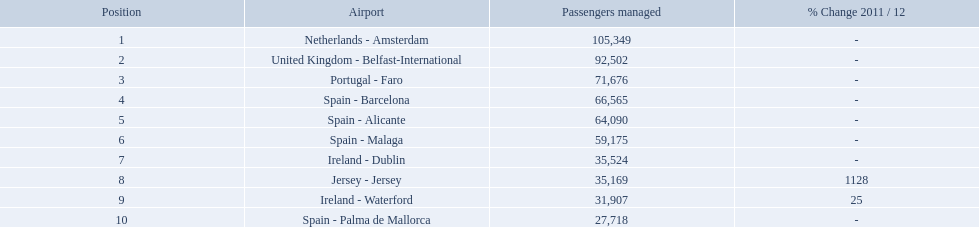What are the airports? Netherlands - Amsterdam, United Kingdom - Belfast-International, Portugal - Faro, Spain - Barcelona, Spain - Alicante, Spain - Malaga, Ireland - Dublin, Jersey - Jersey, Ireland - Waterford, Spain - Palma de Mallorca. Of these which has the least amount of passengers? Spain - Palma de Mallorca. What are the numbers of passengers handled along the different routes in the airport? 105,349, 92,502, 71,676, 66,565, 64,090, 59,175, 35,524, 35,169, 31,907, 27,718. Of these routes, which handles less than 30,000 passengers? Spain - Palma de Mallorca. What are the names of all the airports? Netherlands - Amsterdam, United Kingdom - Belfast-International, Portugal - Faro, Spain - Barcelona, Spain - Alicante, Spain - Malaga, Ireland - Dublin, Jersey - Jersey, Ireland - Waterford, Spain - Palma de Mallorca. Of these, what are all the passenger counts? 105,349, 92,502, 71,676, 66,565, 64,090, 59,175, 35,524, 35,169, 31,907, 27,718. Of these, which airport had more passengers than the united kingdom? Netherlands - Amsterdam. What are all the airports in the top 10 busiest routes to and from london southend airport? Netherlands - Amsterdam, United Kingdom - Belfast-International, Portugal - Faro, Spain - Barcelona, Spain - Alicante, Spain - Malaga, Ireland - Dublin, Jersey - Jersey, Ireland - Waterford, Spain - Palma de Mallorca. Which airports are in portugal? Portugal - Faro. What are all of the routes out of the london southend airport? Netherlands - Amsterdam, United Kingdom - Belfast-International, Portugal - Faro, Spain - Barcelona, Spain - Alicante, Spain - Malaga, Ireland - Dublin, Jersey - Jersey, Ireland - Waterford, Spain - Palma de Mallorca. How many passengers have traveled to each destination? 105,349, 92,502, 71,676, 66,565, 64,090, 59,175, 35,524, 35,169, 31,907, 27,718. And which destination has been the most popular to passengers? Netherlands - Amsterdam. 